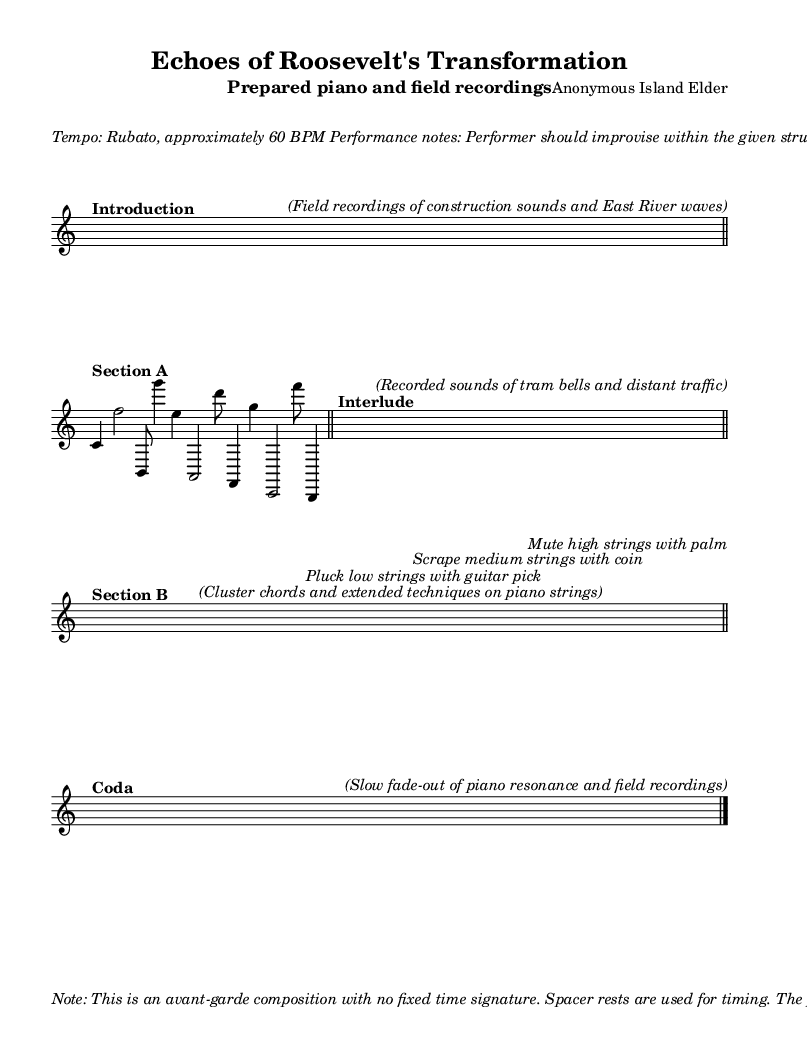What is the title of this piece? The title is located in the header section of the sheet music. It states "Echoes of Roosevelt's Transformation."
Answer: Echoes of Roosevelt's Transformation What is the tempo marking for this piece? The tempo marking is found in the performance notes section. It indicates "Tempo: Rubato, approximately 60 BPM."
Answer: Rubato, approximately 60 BPM What instruments are used in this composition? The instrumentation is indicated in the header of the sheet music. It mentions "Prepared piano and field recordings."
Answer: Prepared piano and field recordings What is the time signature of this composition? The time signature is indicated within the score context. Although the piece has no fixed time signature, it explicitly shows "4/4" when sections are introduced.
Answer: 4/4 What techniques are suggested for Section B? The suggested techniques are found in the markings under Section B. It refers to "Cluster chords and extended techniques on piano strings," with specific actions described.
Answer: Pluck, scrape, mute Why does the composer incorporate field recordings? The composer uses field recordings to evoke the sense of gradual urban change, as mentioned in the performance notes. It adds a layer of context to the avant-garde nature of the composition.
Answer: Urban change How is the Coda structured in terms of sound? The Coda is noted to include a "slow fade-out of piano resonance and field recordings." This suggests the ending will taper off, blending the elements together.
Answer: Slow fade-out 